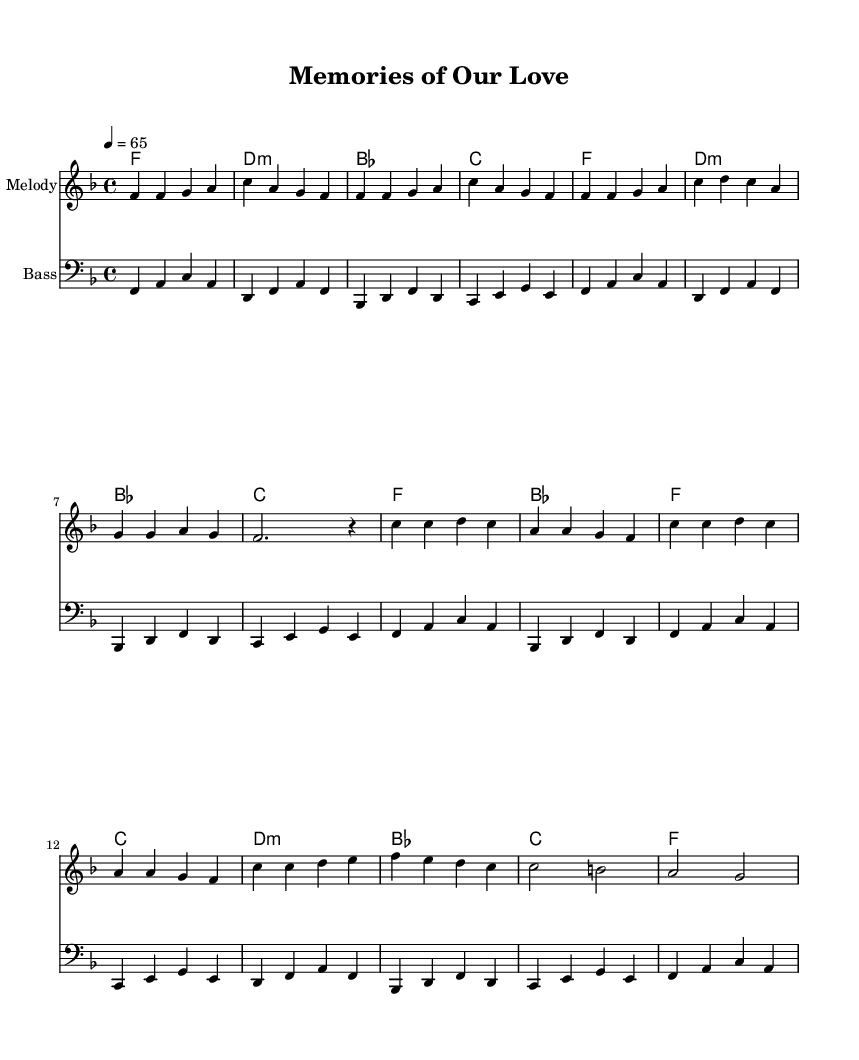What is the key signature of this music? The key signature is F major, which has one flat (B flat). This can be determined by examining the first part of the sheet music where the key signature is indicated.
Answer: F major What is the time signature of the piece? The time signature is 4/4, which indicates there are four beats in each measure and the quarter note gets one beat. This is noted at the beginning of the sheet music after the key signature.
Answer: 4/4 What is the tempo marking? The tempo marking is a quarter note equals 65 beats per minute, indicated at the beginning of the score. This tells us the speed at which the piece should be played.
Answer: 65 How many measures are there in the chorus? The chorus consists of 8 measures, as counted in the section marked for the chorus (from the beginning of the chorus to the end).
Answer: 8 Which chord is played at the end of the verse? The last chord at the end of the verse is F major, as seen in the chord progression beneath the melody for that section, where the final chord is indicated.
Answer: F What characterizes the bassline in this R&B piece? The bassline provides a rhythmic and harmonic foundation, following the root notes of the chords and enhancing the groove typical in smooth R&B ballads. Additionally, it complements the melody to evoke feelings of romance and melancholy.
Answer: Root notes What type of emotional themes are depicted in this ballad? The ballad predominantly explores themes of romance and heartbreak, as indicated by the lyrics and musical expression typical of R&B ballads from the 1970s. This emotional quality can be inferred from the chord choices and melodic lines.
Answer: Romance and heartbreak 